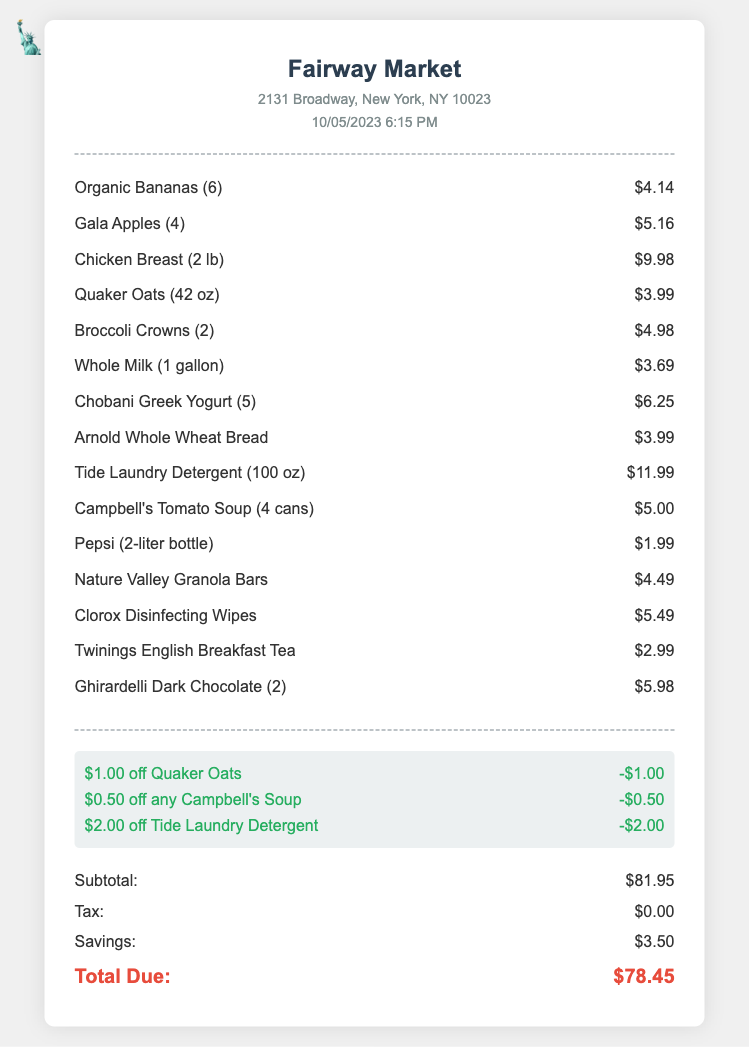what is the store name? The store name is displayed prominently at the top of the document, indicating where the purchase was made.
Answer: Fairway Market what is the total amount due? The total amount due is indicated at the bottom of the receipt where all costs are summarized.
Answer: $78.45 how many organic bananas were purchased? The itemized list shows the quantity of organic bananas purchased as part of the grocery shopping.
Answer: 6 what is the date and time of the transaction? The date and time of the transaction are noted in the header section of the document, providing context for the shopping trip.
Answer: 10/05/2023 6:15 PM what is the subtotal before discounts? The subtotal reflects the total cost of the items purchased before any discount is applied, found in the totals section.
Answer: $81.95 how much was saved with coupons? The savings from using coupons are highlighted in the totals section, summarizing the benefits received from discounts.
Answer: $3.50 which item had the highest price? By comparing the prices listed, we identify which item was the most expensive in the shopping list.
Answer: Tide Laundry Detergent (100 oz) how many cans of Campbell's Tomato Soup were bought? The receipt itemizes the quantity of Campbell's Tomato Soup purchased, specifying the total amount bought.
Answer: 4 cans what kind of milk was purchased? The specific type of milk is detailed in the itemized list, indicating the product category and name.
Answer: Whole Milk (1 gallon) 